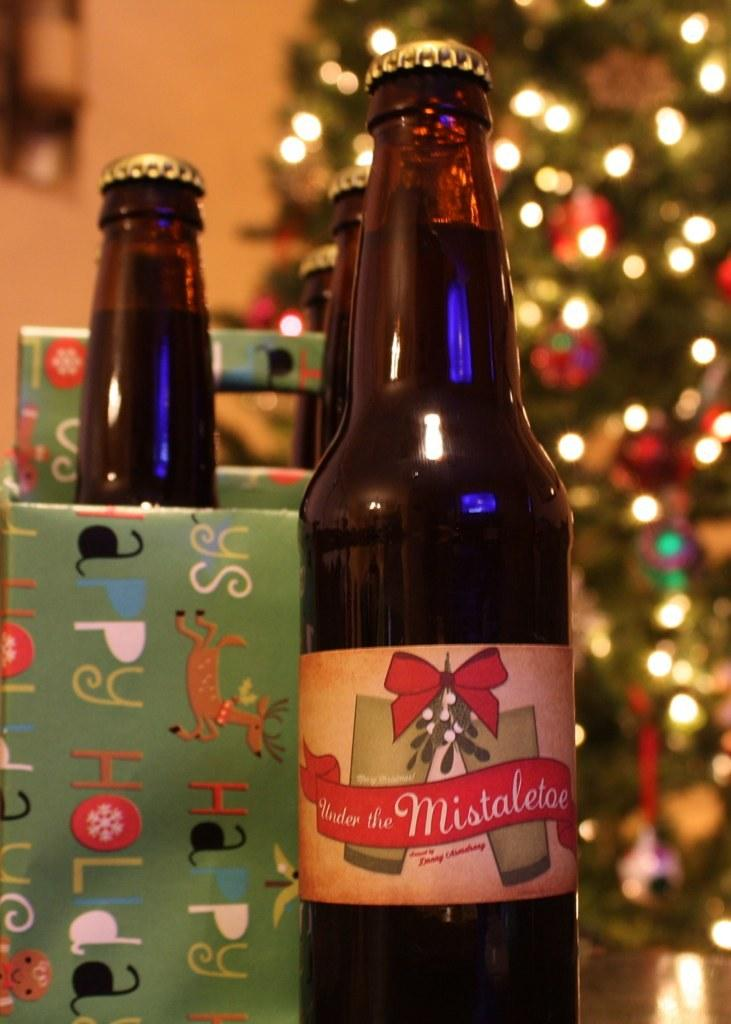What type of beverages are on the table in the image? There are wine bottles on the table in the image. What holiday-related item can be seen in the image? There is an x-mas tree in the image. What architectural feature is visible in the image? There is a wall visible in the image. What type of dock can be seen near the x-mas tree in the image? There is no dock present in the image; it only features wine bottles, an x-mas tree, and a wall. What type of texture is visible on the wall in the image? The provided facts do not mention the texture of the wall, so it cannot be determined from the image. 